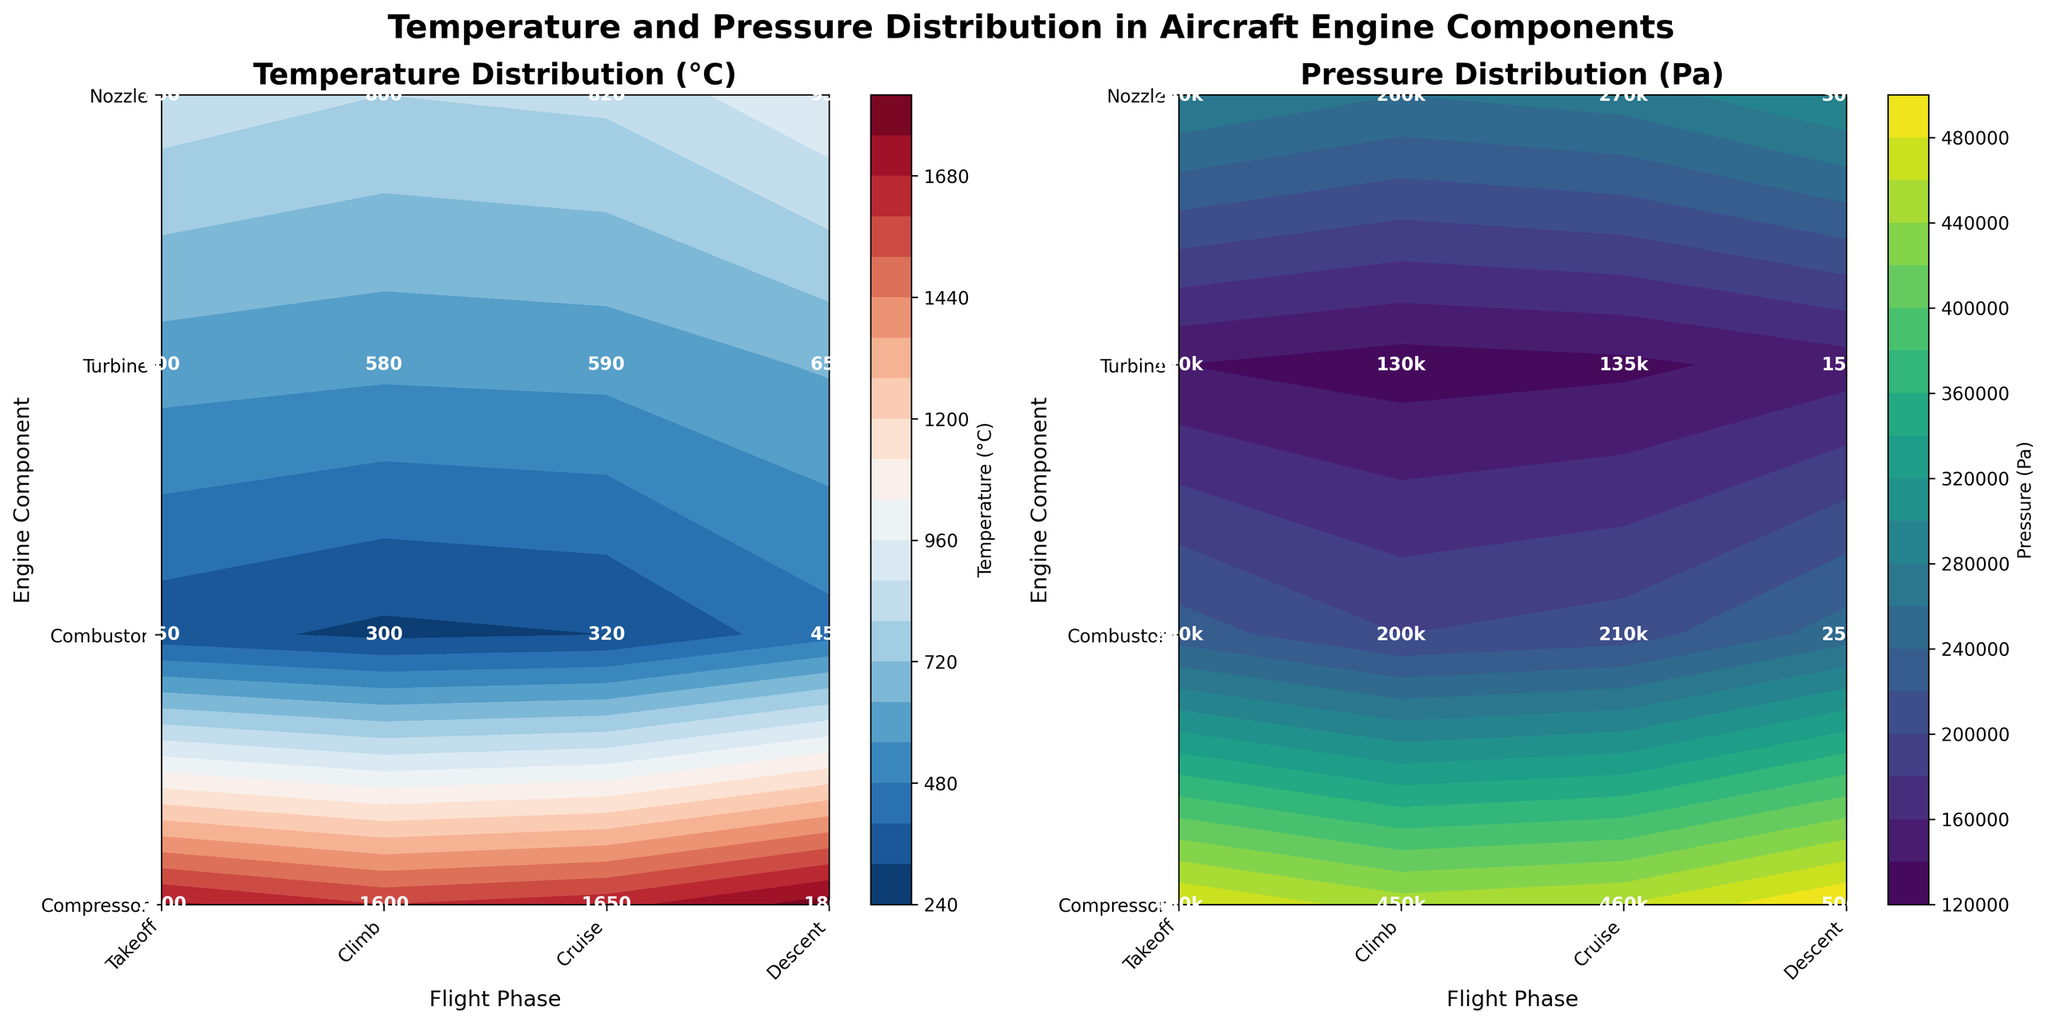What are the highest and lowest temperatures recorded among all engine components during the cruise phase? To find the highest and lowest temperatures during the cruise phase, locate the "Cruise" column in the temperature contour plot, then identify the maximum and minimum values. The highest temperature during the cruise phase is 1600°C in the Combustor, and the lowest is 300°C in the Compressor.
Answer: Highest: 1600°C, Lowest: 300°C What is the average pressure in the Turbine component across all flight phases? To compute the average pressure in the Turbine component, identify the pressure values corresponding to the Turbine row across all phases: 300,000, 280,000, 260,000, and 270,000 Pa. Sum these values: 300,000 + 280,000 + 260,000 + 270,000 = 1,110,000 Pa. Divide by the number of phases (4): 1,110,000 / 4 = 277,500 Pa.
Answer: 277,500 Pa Which component experiences the highest pressure during the takeoff phase and what is its value? To find the component with the highest pressure during the takeoff phase, refer to the "Takeoff" column in the pressure contour plot and identify the maximum value. The Combustor experiences the highest pressure at 500,000 Pa.
Answer: Combustor, 500,000 Pa How does the temperature change in the Nozzle component from takeoff to descent? To observe the change in temperature for the Nozzle component from takeoff to descent, locate the temperature values in the Nozzle row: 650°C during takeoff and 590°C during descent. Calculate the difference: 650 - 590 = 60°C. The temperature decreases by 60°C.
Answer: Decreases by 60°C What is the pressure difference between the Compressor and Combustor during the climb phase? To determine the pressure difference between the Compressor and Combustor during the climb phase, locate the corresponding pressure values: Compressor (230,000 Pa) and Combustor (480,000 Pa). Subtract the Compressor pressure from the Combustor pressure: 480,000 - 230,000 = 250,000 Pa.
Answer: 250,000 Pa Which flight phase shows the smallest temperature difference between the Compressor and Turbine components? To find the smallest temperature difference between Compressor and Turbine components across all phases, compare the temperature differences: Takeoff (450 - 950 = 500°C), Climb (350 - 850 = 500°C), Cruise (300 - 800 = 500°C), and Descent (320 - 820 = 500°C). All phases show a difference of 500°C.
Answer: All phases (500°C) 